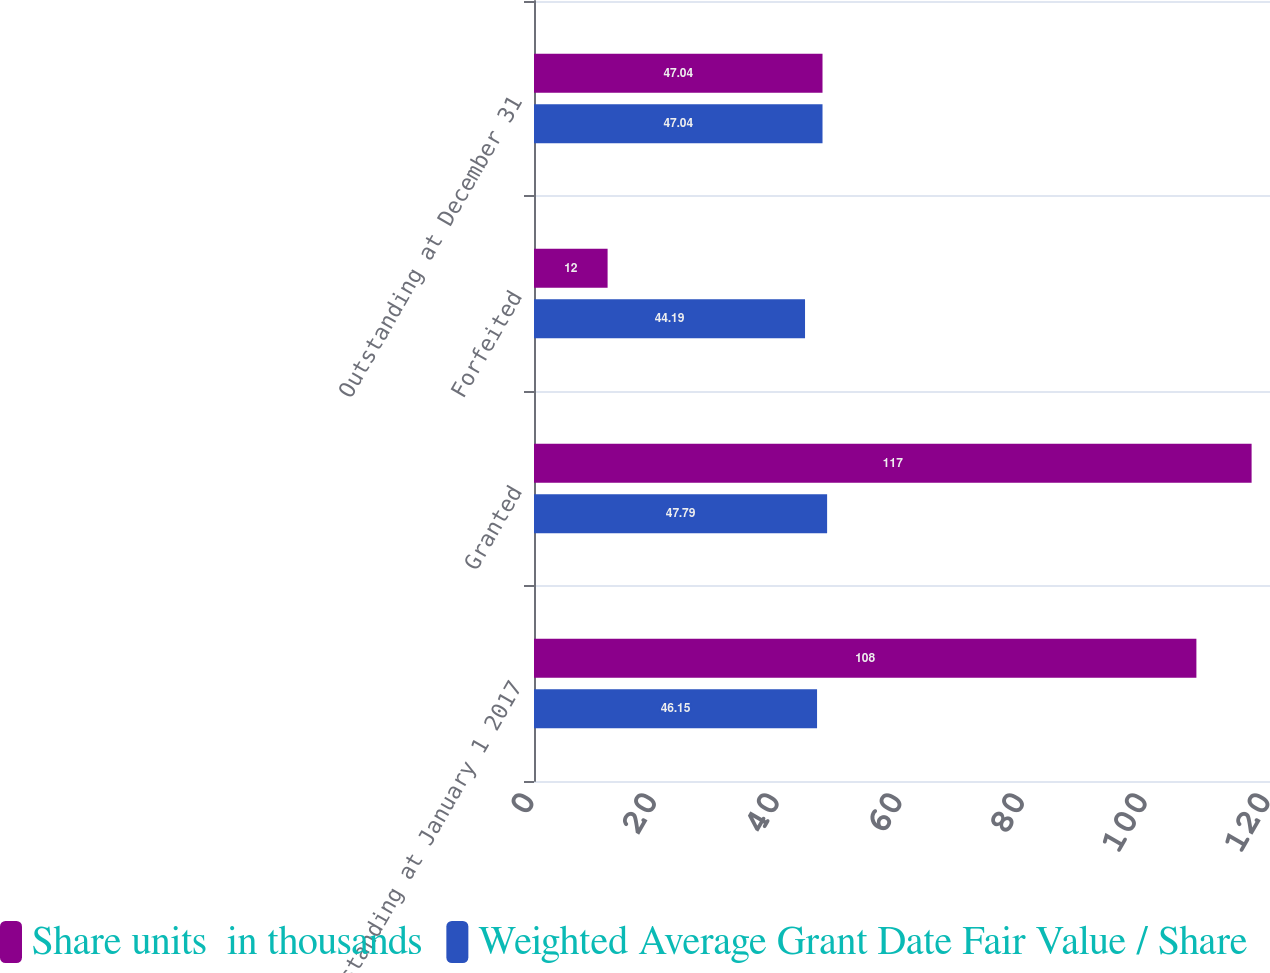Convert chart to OTSL. <chart><loc_0><loc_0><loc_500><loc_500><stacked_bar_chart><ecel><fcel>Outstanding at January 1 2017<fcel>Granted<fcel>Forfeited<fcel>Outstanding at December 31<nl><fcel>Share units  in thousands<fcel>108<fcel>117<fcel>12<fcel>47.04<nl><fcel>Weighted Average Grant Date Fair Value / Share<fcel>46.15<fcel>47.79<fcel>44.19<fcel>47.04<nl></chart> 